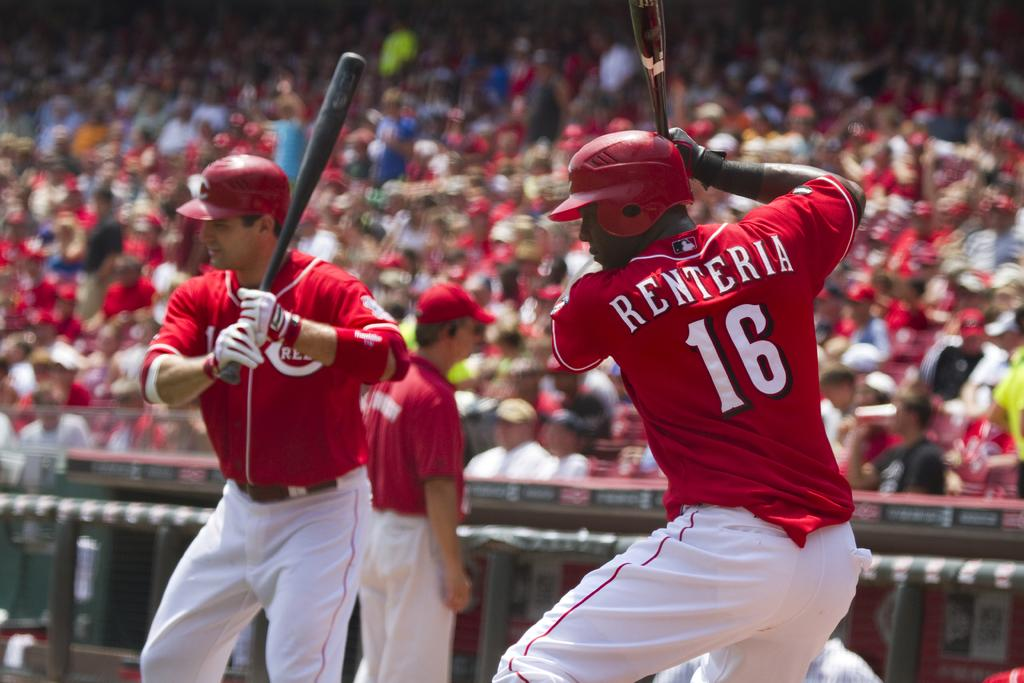<image>
Create a compact narrative representing the image presented. Two baseball players with bats, one with "Renteria 16" on his back. 